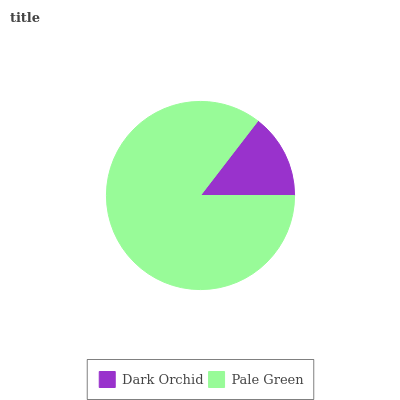Is Dark Orchid the minimum?
Answer yes or no. Yes. Is Pale Green the maximum?
Answer yes or no. Yes. Is Pale Green the minimum?
Answer yes or no. No. Is Pale Green greater than Dark Orchid?
Answer yes or no. Yes. Is Dark Orchid less than Pale Green?
Answer yes or no. Yes. Is Dark Orchid greater than Pale Green?
Answer yes or no. No. Is Pale Green less than Dark Orchid?
Answer yes or no. No. Is Pale Green the high median?
Answer yes or no. Yes. Is Dark Orchid the low median?
Answer yes or no. Yes. Is Dark Orchid the high median?
Answer yes or no. No. Is Pale Green the low median?
Answer yes or no. No. 